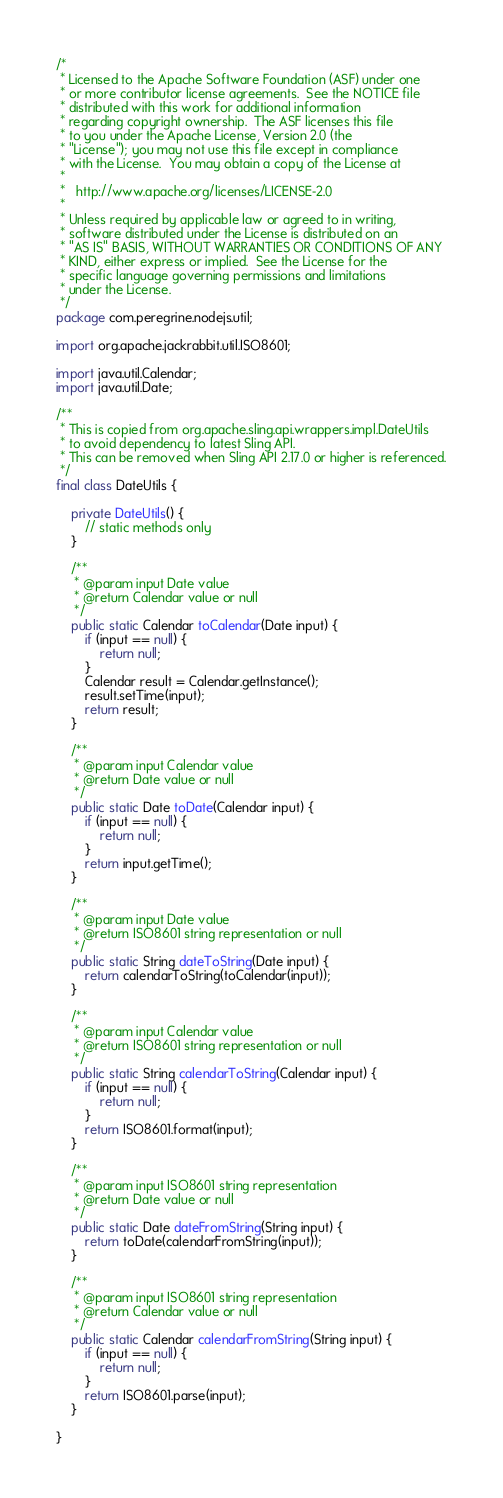<code> <loc_0><loc_0><loc_500><loc_500><_Java_>/*
 * Licensed to the Apache Software Foundation (ASF) under one
 * or more contributor license agreements.  See the NOTICE file
 * distributed with this work for additional information
 * regarding copyright ownership.  The ASF licenses this file
 * to you under the Apache License, Version 2.0 (the
 * "License"); you may not use this file except in compliance
 * with the License.  You may obtain a copy of the License at
 *
 *   http://www.apache.org/licenses/LICENSE-2.0
 *
 * Unless required by applicable law or agreed to in writing,
 * software distributed under the License is distributed on an
 * "AS IS" BASIS, WITHOUT WARRANTIES OR CONDITIONS OF ANY
 * KIND, either express or implied.  See the License for the
 * specific language governing permissions and limitations
 * under the License.
 */
package com.peregrine.nodejs.util;

import org.apache.jackrabbit.util.ISO8601;

import java.util.Calendar;
import java.util.Date;

/**
 * This is copied from org.apache.sling.api.wrappers.impl.DateUtils
 * to avoid dependency to latest Sling API.
 * This can be removed when Sling API 2.17.0 or higher is referenced.
 */
final class DateUtils {
    
    private DateUtils() {
        // static methods only
    }

    /**
     * @param input Date value
     * @return Calendar value or null
     */
    public static Calendar toCalendar(Date input) {
        if (input == null) {
            return null;
        }
        Calendar result = Calendar.getInstance();
        result.setTime(input);
        return result;
    }

    /**
     * @param input Calendar value
     * @return Date value or null
     */
    public static Date toDate(Calendar input) {
        if (input == null) {
            return null;
        }
        return input.getTime();
    }
    
    /**
     * @param input Date value
     * @return ISO8601 string representation or null
     */
    public static String dateToString(Date input) {
        return calendarToString(toCalendar(input));
    }

    /**
     * @param input Calendar value
     * @return ISO8601 string representation or null
     */
    public static String calendarToString(Calendar input) {
        if (input == null) {
            return null;
        }
        return ISO8601.format(input);
    }

    /**
     * @param input ISO8601 string representation
     * @return Date value or null
     */
    public static Date dateFromString(String input) {
        return toDate(calendarFromString(input));
    }

    /**
     * @param input ISO8601 string representation
     * @return Calendar value or null
     */
    public static Calendar calendarFromString(String input) {
        if (input == null) {
            return null;
        }
        return ISO8601.parse(input);
    }

}
</code> 